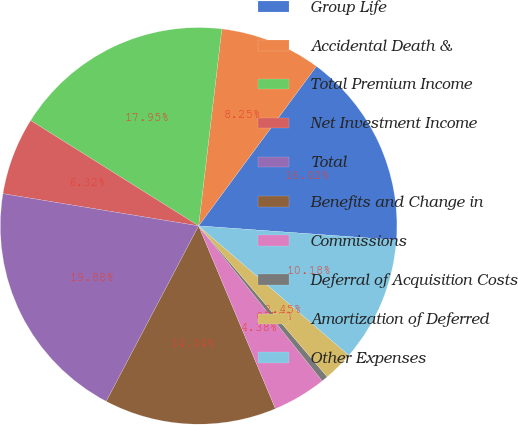<chart> <loc_0><loc_0><loc_500><loc_500><pie_chart><fcel>Group Life<fcel>Accidental Death &<fcel>Total Premium Income<fcel>Net Investment Income<fcel>Total<fcel>Benefits and Change in<fcel>Commissions<fcel>Deferral of Acquisition Costs<fcel>Amortization of Deferred<fcel>Other Expenses<nl><fcel>16.02%<fcel>8.25%<fcel>17.95%<fcel>6.32%<fcel>19.88%<fcel>14.04%<fcel>4.38%<fcel>0.52%<fcel>2.45%<fcel>10.18%<nl></chart> 